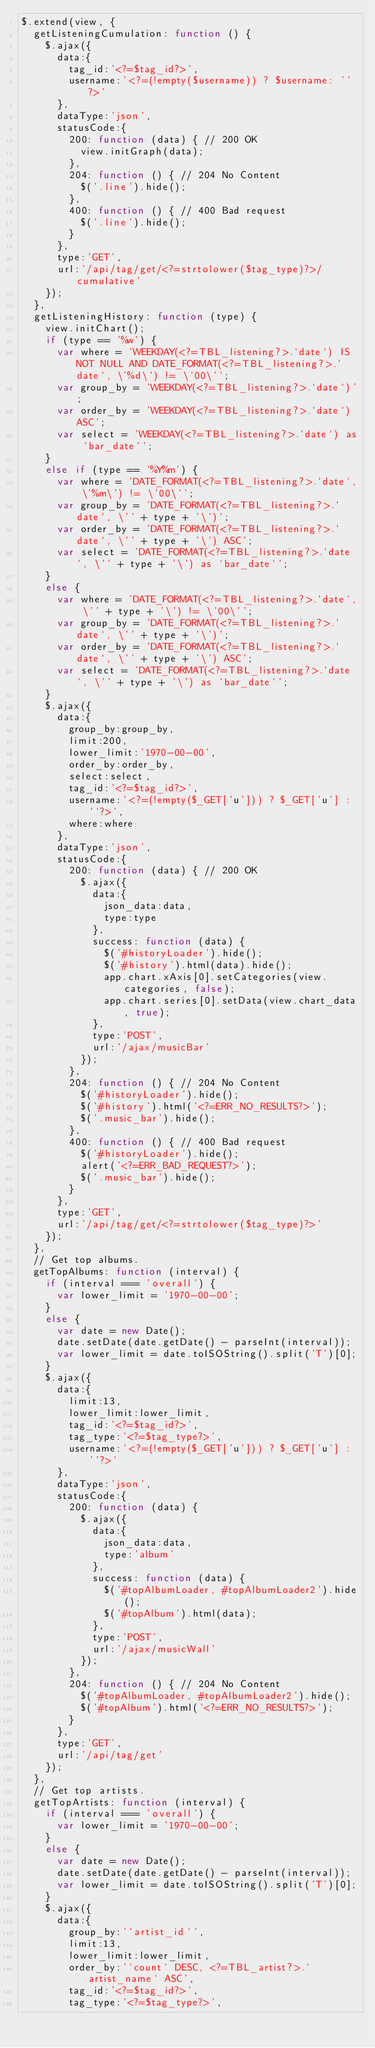Convert code to text. <code><loc_0><loc_0><loc_500><loc_500><_JavaScript_>$.extend(view, {
  getListeningCumulation: function () {
    $.ajax({
      data:{
        tag_id:'<?=$tag_id?>',
        username:'<?=(!empty($username)) ? $username: ''?>'
      },
      dataType:'json',
      statusCode:{
        200: function (data) { // 200 OK
          view.initGraph(data);
        },
        204: function () { // 204 No Content
          $('.line').hide();
        },
        400: function () { // 400 Bad request
          $('.line').hide();
        }
      },
      type:'GET',
      url:'/api/tag/get/<?=strtolower($tag_type)?>/cumulative'
    });
  },
  getListeningHistory: function (type) {
    view.initChart();
    if (type == '%w') {
      var where = 'WEEKDAY(<?=TBL_listening?>.`date`) IS NOT NULL AND DATE_FORMAT(<?=TBL_listening?>.`date`, \'%d\') != \'00\'';
      var group_by = 'WEEKDAY(<?=TBL_listening?>.`date`)';
      var order_by = 'WEEKDAY(<?=TBL_listening?>.`date`) ASC';
      var select = 'WEEKDAY(<?=TBL_listening?>.`date`) as `bar_date`';
    }
    else if (type == '%Y%m') {
      var where = 'DATE_FORMAT(<?=TBL_listening?>.`date`, \'%m\') != \'00\'';
      var group_by = 'DATE_FORMAT(<?=TBL_listening?>.`date`, \'' + type + '\')';
      var order_by = 'DATE_FORMAT(<?=TBL_listening?>.`date`, \'' + type + '\') ASC';
      var select = 'DATE_FORMAT(<?=TBL_listening?>.`date`, \'' + type + '\') as `bar_date`';
    }
    else {
      var where = 'DATE_FORMAT(<?=TBL_listening?>.`date`, \'' + type + '\') != \'00\'';
      var group_by = 'DATE_FORMAT(<?=TBL_listening?>.`date`, \'' + type + '\')';
      var order_by = 'DATE_FORMAT(<?=TBL_listening?>.`date`, \'' + type + '\') ASC';
      var select = 'DATE_FORMAT(<?=TBL_listening?>.`date`, \'' + type + '\') as `bar_date`';
    }
    $.ajax({
      data:{
        group_by:group_by,
        limit:200,
        lower_limit:'1970-00-00',
        order_by:order_by,
        select:select,
        tag_id:'<?=$tag_id?>',
        username:'<?=(!empty($_GET['u'])) ? $_GET['u'] : ''?>',
        where:where
      },
      dataType:'json',
      statusCode:{
        200: function (data) { // 200 OK
          $.ajax({
            data:{
              json_data:data,
              type:type
            },
            success: function (data) {
              $('#historyLoader').hide();
              $('#history').html(data).hide();
              app.chart.xAxis[0].setCategories(view.categories, false);
              app.chart.series[0].setData(view.chart_data, true);
            },
            type:'POST',
            url:'/ajax/musicBar'
          });
        },
        204: function () { // 204 No Content
          $('#historyLoader').hide();
          $('#history').html('<?=ERR_NO_RESULTS?>');
          $('.music_bar').hide();
        },
        400: function () { // 400 Bad request
          $('#historyLoader').hide();
          alert('<?=ERR_BAD_REQUEST?>');
          $('.music_bar').hide();
        }
      },
      type:'GET',
      url:'/api/tag/get/<?=strtolower($tag_type)?>'
    });
  },
  // Get top albums.
  getTopAlbums: function (interval) {
    if (interval === 'overall') {
      var lower_limit = '1970-00-00';
    }
    else {
      var date = new Date();
      date.setDate(date.getDate() - parseInt(interval));
      var lower_limit = date.toISOString().split('T')[0];
    }
    $.ajax({
      data:{
        limit:13,
        lower_limit:lower_limit,
        tag_id:'<?=$tag_id?>',
        tag_type:'<?=$tag_type?>',
        username:'<?=(!empty($_GET['u'])) ? $_GET['u'] : ''?>'
      },
      dataType:'json',
      statusCode:{
        200: function (data) {
          $.ajax({
            data:{
              json_data:data,
              type:'album'
            },
            success: function (data) {
              $('#topAlbumLoader, #topAlbumLoader2').hide();
              $('#topAlbum').html(data);
            },
            type:'POST',
            url:'/ajax/musicWall'
          });
        },
        204: function () { // 204 No Content
          $('#topAlbumLoader, #topAlbumLoader2').hide();
          $('#topAlbum').html('<?=ERR_NO_RESULTS?>');
        }
      },
      type:'GET',
      url:'/api/tag/get'
    });
  },
  // Get top artists.
  getTopArtists: function (interval) {
    if (interval === 'overall') {
      var lower_limit = '1970-00-00';
    }
    else {
      var date = new Date();
      date.setDate(date.getDate() - parseInt(interval));
      var lower_limit = date.toISOString().split('T')[0];
    }
    $.ajax({
      data:{
        group_by:'`artist_id`',
        limit:13,
        lower_limit:lower_limit,
        order_by:'`count` DESC, <?=TBL_artist?>.`artist_name` ASC',
        tag_id:'<?=$tag_id?>',
        tag_type:'<?=$tag_type?>',</code> 